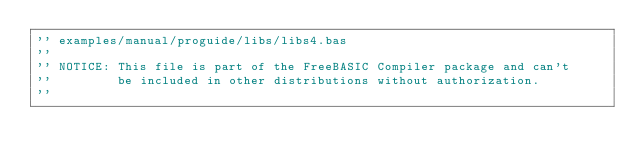Convert code to text. <code><loc_0><loc_0><loc_500><loc_500><_VisualBasic_>'' examples/manual/proguide/libs/libs4.bas
''
'' NOTICE: This file is part of the FreeBASIC Compiler package and can't
''         be included in other distributions without authorization.
''</code> 